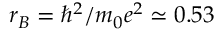Convert formula to latex. <formula><loc_0><loc_0><loc_500><loc_500>r _ { B } = \hbar { ^ } { 2 } / m _ { 0 } e ^ { 2 } \simeq 0 . 5 3</formula> 